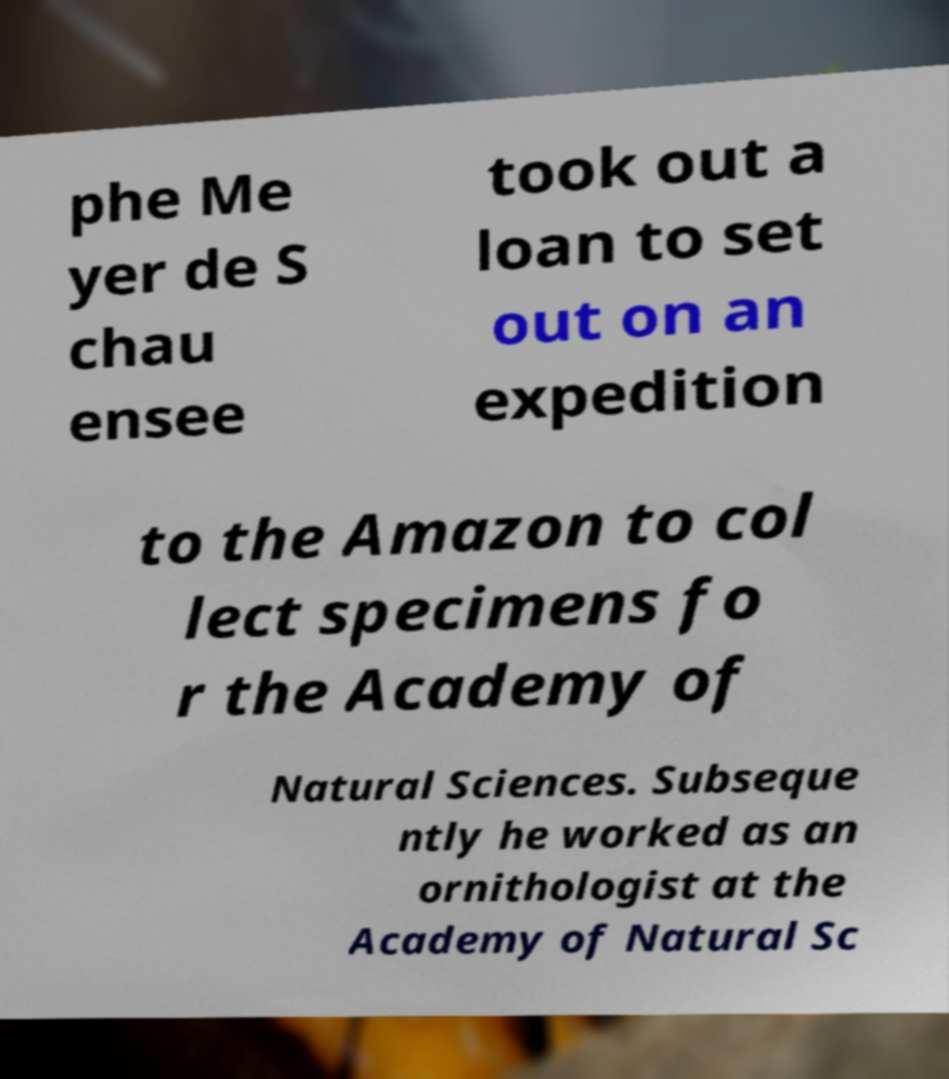There's text embedded in this image that I need extracted. Can you transcribe it verbatim? phe Me yer de S chau ensee took out a loan to set out on an expedition to the Amazon to col lect specimens fo r the Academy of Natural Sciences. Subseque ntly he worked as an ornithologist at the Academy of Natural Sc 